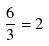<formula> <loc_0><loc_0><loc_500><loc_500>\frac { 6 } { 3 } = 2</formula> 